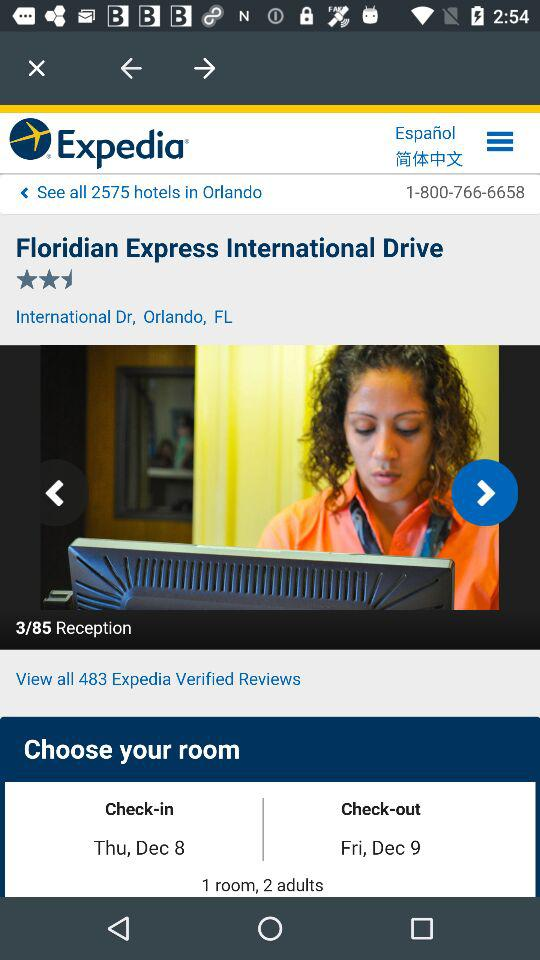What's the total number of hotels in Orlando? The total number of hotels in Orlando is 2575. 